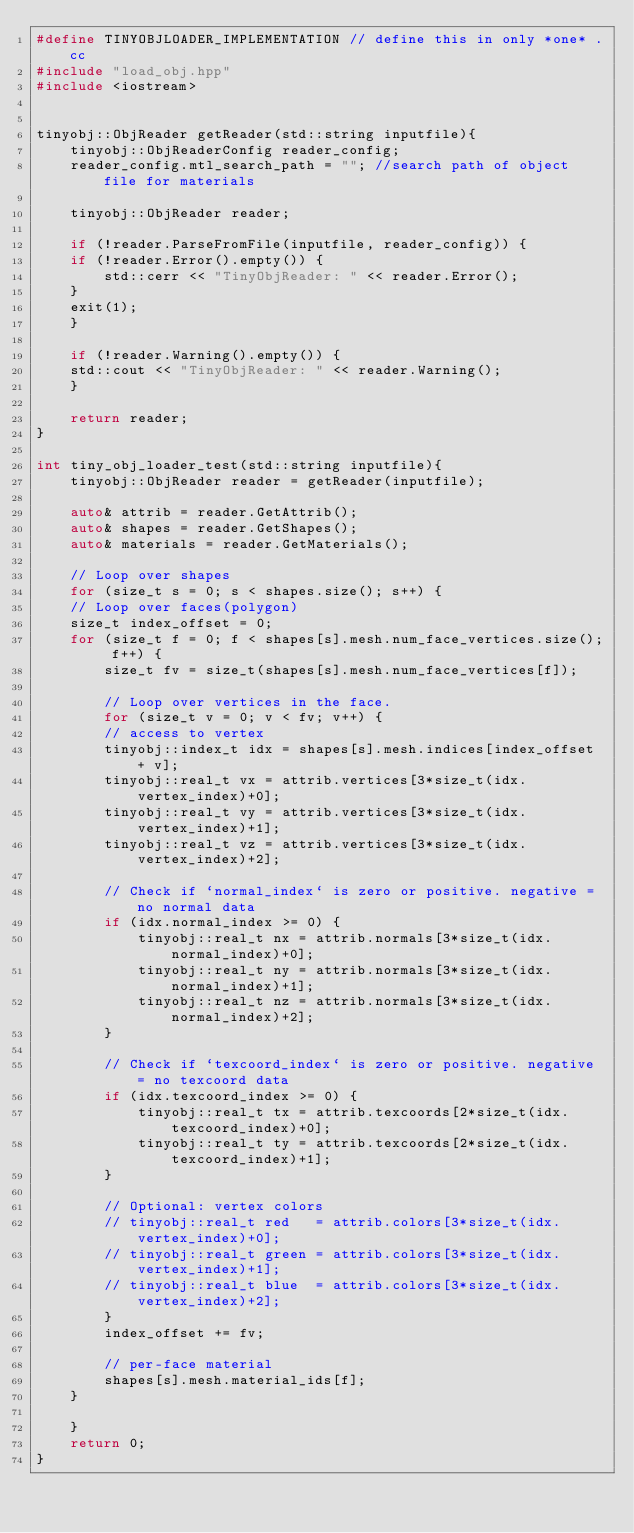Convert code to text. <code><loc_0><loc_0><loc_500><loc_500><_C++_>#define TINYOBJLOADER_IMPLEMENTATION // define this in only *one* .cc
#include "load_obj.hpp"
#include <iostream>


tinyobj::ObjReader getReader(std::string inputfile){
    tinyobj::ObjReaderConfig reader_config;
    reader_config.mtl_search_path = ""; //search path of object file for materials

    tinyobj::ObjReader reader;

    if (!reader.ParseFromFile(inputfile, reader_config)) {
    if (!reader.Error().empty()) {
        std::cerr << "TinyObjReader: " << reader.Error();
    }
    exit(1);
    }

    if (!reader.Warning().empty()) {
    std::cout << "TinyObjReader: " << reader.Warning();
    }

    return reader;
}

int tiny_obj_loader_test(std::string inputfile){
    tinyobj::ObjReader reader = getReader(inputfile);

    auto& attrib = reader.GetAttrib();
    auto& shapes = reader.GetShapes();
    auto& materials = reader.GetMaterials();

    // Loop over shapes
    for (size_t s = 0; s < shapes.size(); s++) {
    // Loop over faces(polygon)
    size_t index_offset = 0;
    for (size_t f = 0; f < shapes[s].mesh.num_face_vertices.size(); f++) {
        size_t fv = size_t(shapes[s].mesh.num_face_vertices[f]);

        // Loop over vertices in the face.
        for (size_t v = 0; v < fv; v++) {
        // access to vertex
        tinyobj::index_t idx = shapes[s].mesh.indices[index_offset + v];
        tinyobj::real_t vx = attrib.vertices[3*size_t(idx.vertex_index)+0];
        tinyobj::real_t vy = attrib.vertices[3*size_t(idx.vertex_index)+1];
        tinyobj::real_t vz = attrib.vertices[3*size_t(idx.vertex_index)+2];
    
        // Check if `normal_index` is zero or positive. negative = no normal data
        if (idx.normal_index >= 0) {
            tinyobj::real_t nx = attrib.normals[3*size_t(idx.normal_index)+0];
            tinyobj::real_t ny = attrib.normals[3*size_t(idx.normal_index)+1];
            tinyobj::real_t nz = attrib.normals[3*size_t(idx.normal_index)+2];
        }

        // Check if `texcoord_index` is zero or positive. negative = no texcoord data
        if (idx.texcoord_index >= 0) {
            tinyobj::real_t tx = attrib.texcoords[2*size_t(idx.texcoord_index)+0];
            tinyobj::real_t ty = attrib.texcoords[2*size_t(idx.texcoord_index)+1];
        }

        // Optional: vertex colors
        // tinyobj::real_t red   = attrib.colors[3*size_t(idx.vertex_index)+0];
        // tinyobj::real_t green = attrib.colors[3*size_t(idx.vertex_index)+1];
        // tinyobj::real_t blue  = attrib.colors[3*size_t(idx.vertex_index)+2];
        }
        index_offset += fv;

        // per-face material
        shapes[s].mesh.material_ids[f];
    }

    }
    return 0;
}</code> 